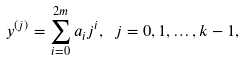Convert formula to latex. <formula><loc_0><loc_0><loc_500><loc_500>y ^ { ( j ) } = \sum _ { i = 0 } ^ { 2 m } a _ { i } j ^ { i } , \ j = 0 , 1 , \dots , k - 1 ,</formula> 